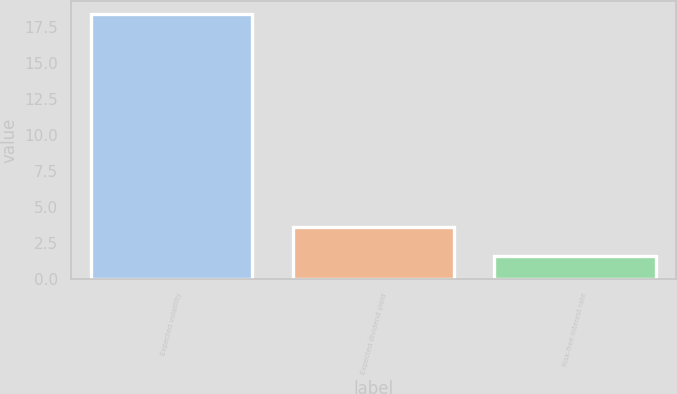<chart> <loc_0><loc_0><loc_500><loc_500><bar_chart><fcel>Expected volatility<fcel>Expected dividend yield<fcel>Risk-free interest rate<nl><fcel>18.4<fcel>3.6<fcel>1.6<nl></chart> 